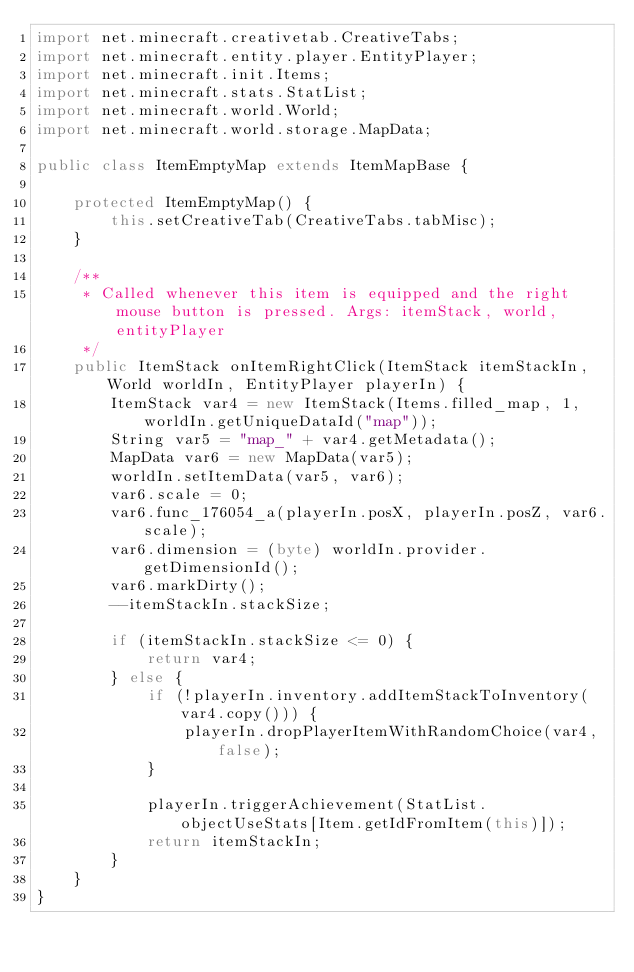<code> <loc_0><loc_0><loc_500><loc_500><_Java_>import net.minecraft.creativetab.CreativeTabs;
import net.minecraft.entity.player.EntityPlayer;
import net.minecraft.init.Items;
import net.minecraft.stats.StatList;
import net.minecraft.world.World;
import net.minecraft.world.storage.MapData;

public class ItemEmptyMap extends ItemMapBase {

    protected ItemEmptyMap() {
        this.setCreativeTab(CreativeTabs.tabMisc);
    }

    /**
     * Called whenever this item is equipped and the right mouse button is pressed. Args: itemStack, world, entityPlayer
     */
    public ItemStack onItemRightClick(ItemStack itemStackIn, World worldIn, EntityPlayer playerIn) {
        ItemStack var4 = new ItemStack(Items.filled_map, 1, worldIn.getUniqueDataId("map"));
        String var5 = "map_" + var4.getMetadata();
        MapData var6 = new MapData(var5);
        worldIn.setItemData(var5, var6);
        var6.scale = 0;
        var6.func_176054_a(playerIn.posX, playerIn.posZ, var6.scale);
        var6.dimension = (byte) worldIn.provider.getDimensionId();
        var6.markDirty();
        --itemStackIn.stackSize;

        if (itemStackIn.stackSize <= 0) {
            return var4;
        } else {
            if (!playerIn.inventory.addItemStackToInventory(var4.copy())) {
                playerIn.dropPlayerItemWithRandomChoice(var4, false);
            }

            playerIn.triggerAchievement(StatList.objectUseStats[Item.getIdFromItem(this)]);
            return itemStackIn;
        }
    }
}
</code> 